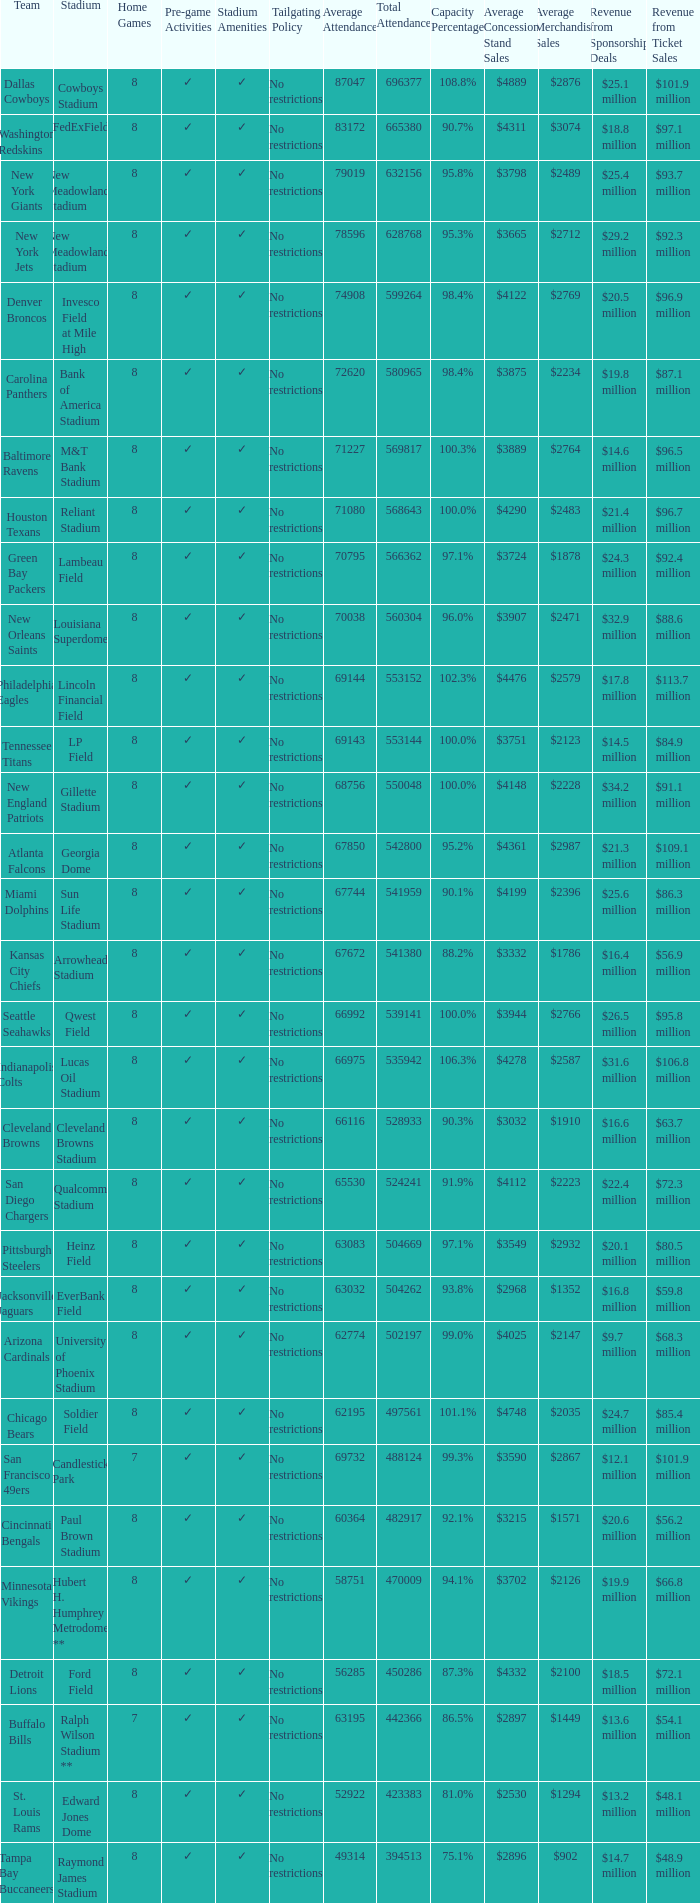How many teams had a 99.3% capacity rating? 1.0. 